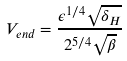Convert formula to latex. <formula><loc_0><loc_0><loc_500><loc_500>V _ { e n d } = \frac { \epsilon ^ { 1 / 4 } \sqrt { \delta _ { H } } } { 2 ^ { 5 / 4 } \sqrt { \beta } }</formula> 